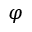Convert formula to latex. <formula><loc_0><loc_0><loc_500><loc_500>\varphi</formula> 